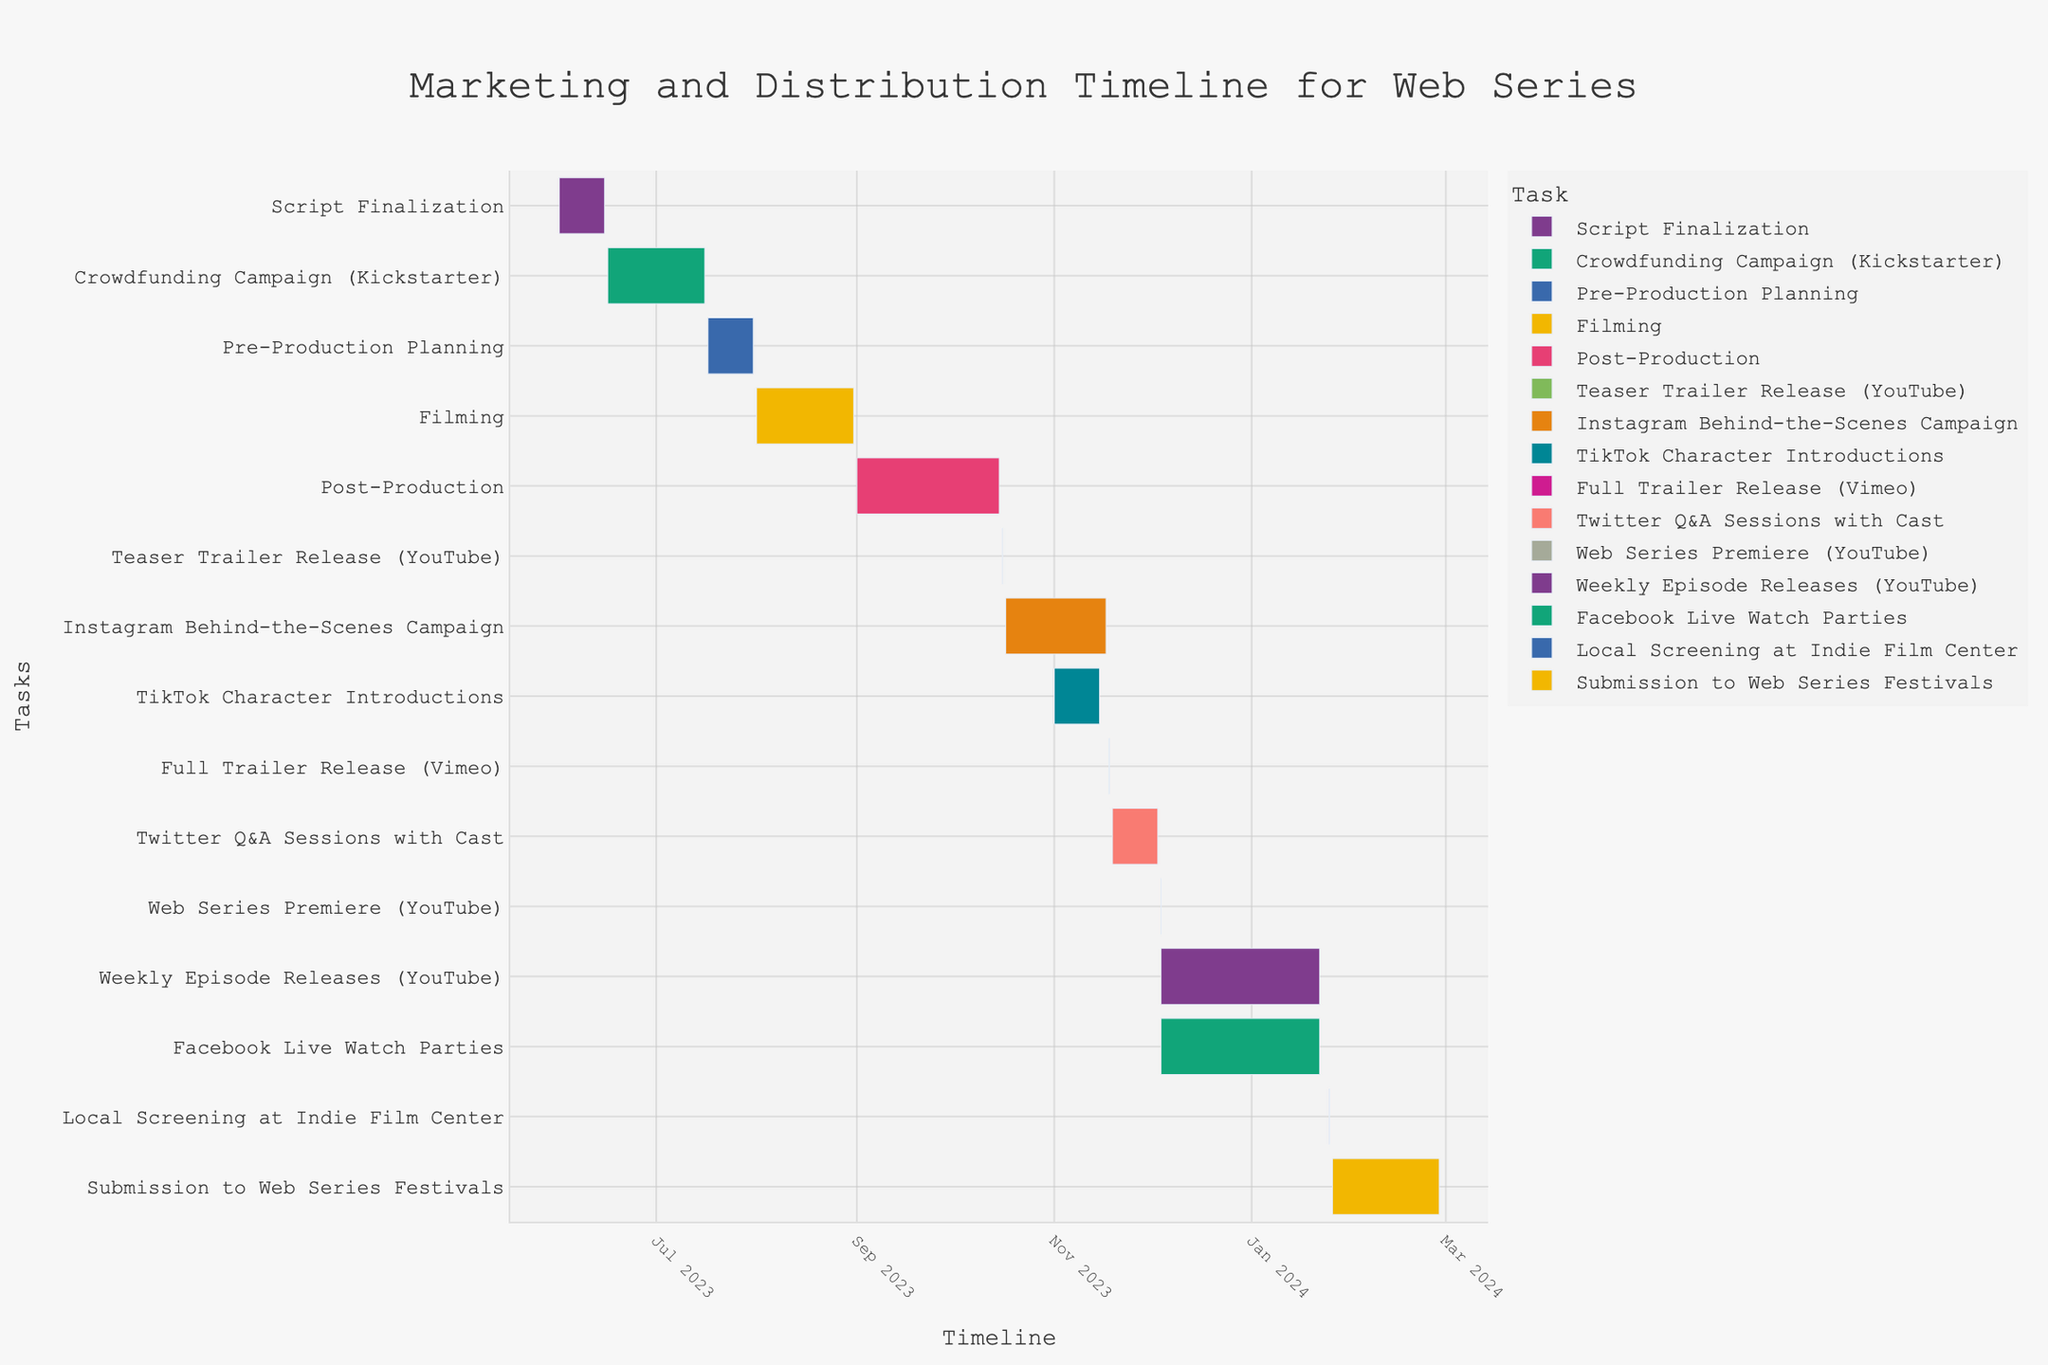What is the title of the chart? The title of the chart can be found at the top of the figure, which is usually prominently displayed and summarises the main content of the chart.
Answer: Marketing and Distribution Timeline for Web Series What is the total duration of the Filming phase? To find the duration, you need to subtract the start date from the end date for the Filming phase. The start date for Filming is August 1, 2023, and the end date is August 31, 2023. Subtracting these dates gives you the duration.
Answer: 31 days When does the Teaser Trailer Release on YouTube happen? Look for the task labeled "Teaser Trailer Release (YouTube)" on the Gantt chart. The start and end date for this task will show the date it happens.
Answer: October 16, 2023 Which task runs longer: Post-Production or Crowdfunding Campaign? To compare the durations, calculate the number of days for each task: Post-Production (September 1, 2023, to October 15, 2023) and Crowdfunding Campaign (June 16, 2023, to July 16, 2023). Post-Production is from September 1 to October 15 (45 days) and Crowdfunding Campaign is from June 16 to July 16 (31 days). Thus, Post-Production runs longer.
Answer: Post-Production How many tasks are scheduled to start in November 2023? Look at the start dates of all tasks and count how many begin in November 2023. In this case, the tasks that start in November 2023 are "Instagram Behind-the-Scenes Campaign" (November 1) and "TikTok Character Introductions" (November 1).
Answer: 2 What comes immediately after the Weekly Episode Releases on YouTube? Check the sequence of tasks after "Weekly Episode Releases (YouTube)". The Weekly Episode Releases end on January 22, 2024. The next task is "Local Screening at Indie Film Center" on January 25, 2024.
Answer: Local Screening at Indie Film Center What is the duration of the Weekly Episode Releases on YouTube? The Weekly Episode Releases start on December 4, 2023, and end on January 22, 2024. Subtracting the start date from the end date gives us the duration.
Answer: 50 days Are there any tasks that start and end on the same day? Look at the start and end dates of each task on the Gantt chart to determine if any task starts and ends on the same day. "Teaser Trailer Release (YouTube)" and "Full Trailer Release (Vimeo)" both start and end on the same day.
Answer: Yes When does the Web Series Premiere on YouTube take place? Locate the task "Web Series Premiere (YouTube)" on the Gantt chart to find its date.
Answer: December 4, 2023 